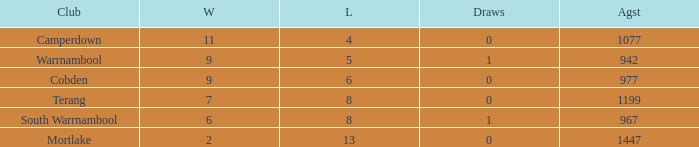How many draws did Mortlake have when the losses were more than 5? 1.0. 